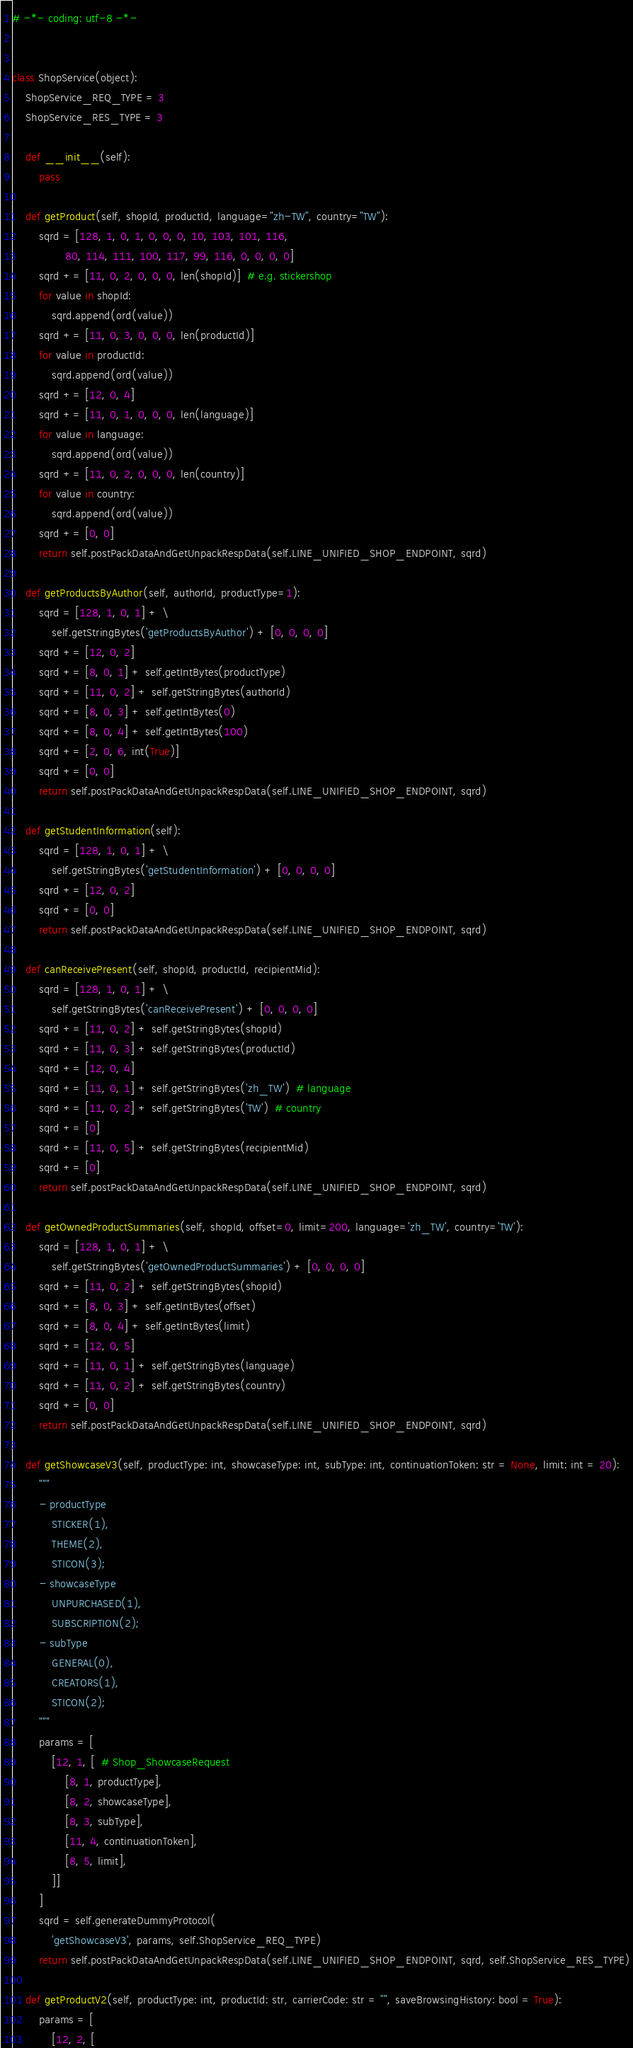Convert code to text. <code><loc_0><loc_0><loc_500><loc_500><_Python_># -*- coding: utf-8 -*-


class ShopService(object):
    ShopService_REQ_TYPE = 3
    ShopService_RES_TYPE = 3

    def __init__(self):
        pass

    def getProduct(self, shopId, productId, language="zh-TW", country="TW"):
        sqrd = [128, 1, 0, 1, 0, 0, 0, 10, 103, 101, 116,
                80, 114, 111, 100, 117, 99, 116, 0, 0, 0, 0]
        sqrd += [11, 0, 2, 0, 0, 0, len(shopId)]  # e.g. stickershop
        for value in shopId:
            sqrd.append(ord(value))
        sqrd += [11, 0, 3, 0, 0, 0, len(productId)]
        for value in productId:
            sqrd.append(ord(value))
        sqrd += [12, 0, 4]
        sqrd += [11, 0, 1, 0, 0, 0, len(language)]
        for value in language:
            sqrd.append(ord(value))
        sqrd += [11, 0, 2, 0, 0, 0, len(country)]
        for value in country:
            sqrd.append(ord(value))
        sqrd += [0, 0]
        return self.postPackDataAndGetUnpackRespData(self.LINE_UNIFIED_SHOP_ENDPOINT, sqrd)

    def getProductsByAuthor(self, authorId, productType=1):
        sqrd = [128, 1, 0, 1] + \
            self.getStringBytes('getProductsByAuthor') + [0, 0, 0, 0]
        sqrd += [12, 0, 2]
        sqrd += [8, 0, 1] + self.getIntBytes(productType)
        sqrd += [11, 0, 2] + self.getStringBytes(authorId)
        sqrd += [8, 0, 3] + self.getIntBytes(0)
        sqrd += [8, 0, 4] + self.getIntBytes(100)
        sqrd += [2, 0, 6, int(True)]
        sqrd += [0, 0]
        return self.postPackDataAndGetUnpackRespData(self.LINE_UNIFIED_SHOP_ENDPOINT, sqrd)

    def getStudentInformation(self):
        sqrd = [128, 1, 0, 1] + \
            self.getStringBytes('getStudentInformation') + [0, 0, 0, 0]
        sqrd += [12, 0, 2]
        sqrd += [0, 0]
        return self.postPackDataAndGetUnpackRespData(self.LINE_UNIFIED_SHOP_ENDPOINT, sqrd)

    def canReceivePresent(self, shopId, productId, recipientMid):
        sqrd = [128, 1, 0, 1] + \
            self.getStringBytes('canReceivePresent') + [0, 0, 0, 0]
        sqrd += [11, 0, 2] + self.getStringBytes(shopId)
        sqrd += [11, 0, 3] + self.getStringBytes(productId)
        sqrd += [12, 0, 4]
        sqrd += [11, 0, 1] + self.getStringBytes('zh_TW')  # language
        sqrd += [11, 0, 2] + self.getStringBytes('TW')  # country
        sqrd += [0]
        sqrd += [11, 0, 5] + self.getStringBytes(recipientMid)
        sqrd += [0]
        return self.postPackDataAndGetUnpackRespData(self.LINE_UNIFIED_SHOP_ENDPOINT, sqrd)

    def getOwnedProductSummaries(self, shopId, offset=0, limit=200, language='zh_TW', country='TW'):
        sqrd = [128, 1, 0, 1] + \
            self.getStringBytes('getOwnedProductSummaries') + [0, 0, 0, 0]
        sqrd += [11, 0, 2] + self.getStringBytes(shopId)
        sqrd += [8, 0, 3] + self.getIntBytes(offset)
        sqrd += [8, 0, 4] + self.getIntBytes(limit)
        sqrd += [12, 0, 5]
        sqrd += [11, 0, 1] + self.getStringBytes(language)
        sqrd += [11, 0, 2] + self.getStringBytes(country)
        sqrd += [0, 0]
        return self.postPackDataAndGetUnpackRespData(self.LINE_UNIFIED_SHOP_ENDPOINT, sqrd)

    def getShowcaseV3(self, productType: int, showcaseType: int, subType: int, continuationToken: str = None, limit: int = 20):
        """
        - productType
            STICKER(1),
            THEME(2),
            STICON(3);
        - showcaseType
            UNPURCHASED(1),
            SUBSCRIPTION(2);
        - subType
            GENERAL(0),
            CREATORS(1),
            STICON(2);
        """
        params = [
            [12, 1, [  # Shop_ShowcaseRequest
                [8, 1, productType],
                [8, 2, showcaseType],
                [8, 3, subType],
                [11, 4, continuationToken],
                [8, 5, limit],
            ]]
        ]
        sqrd = self.generateDummyProtocol(
            'getShowcaseV3', params, self.ShopService_REQ_TYPE)
        return self.postPackDataAndGetUnpackRespData(self.LINE_UNIFIED_SHOP_ENDPOINT, sqrd, self.ShopService_RES_TYPE)

    def getProductV2(self, productType: int, productId: str, carrierCode: str = "", saveBrowsingHistory: bool = True):
        params = [
            [12, 2, [</code> 